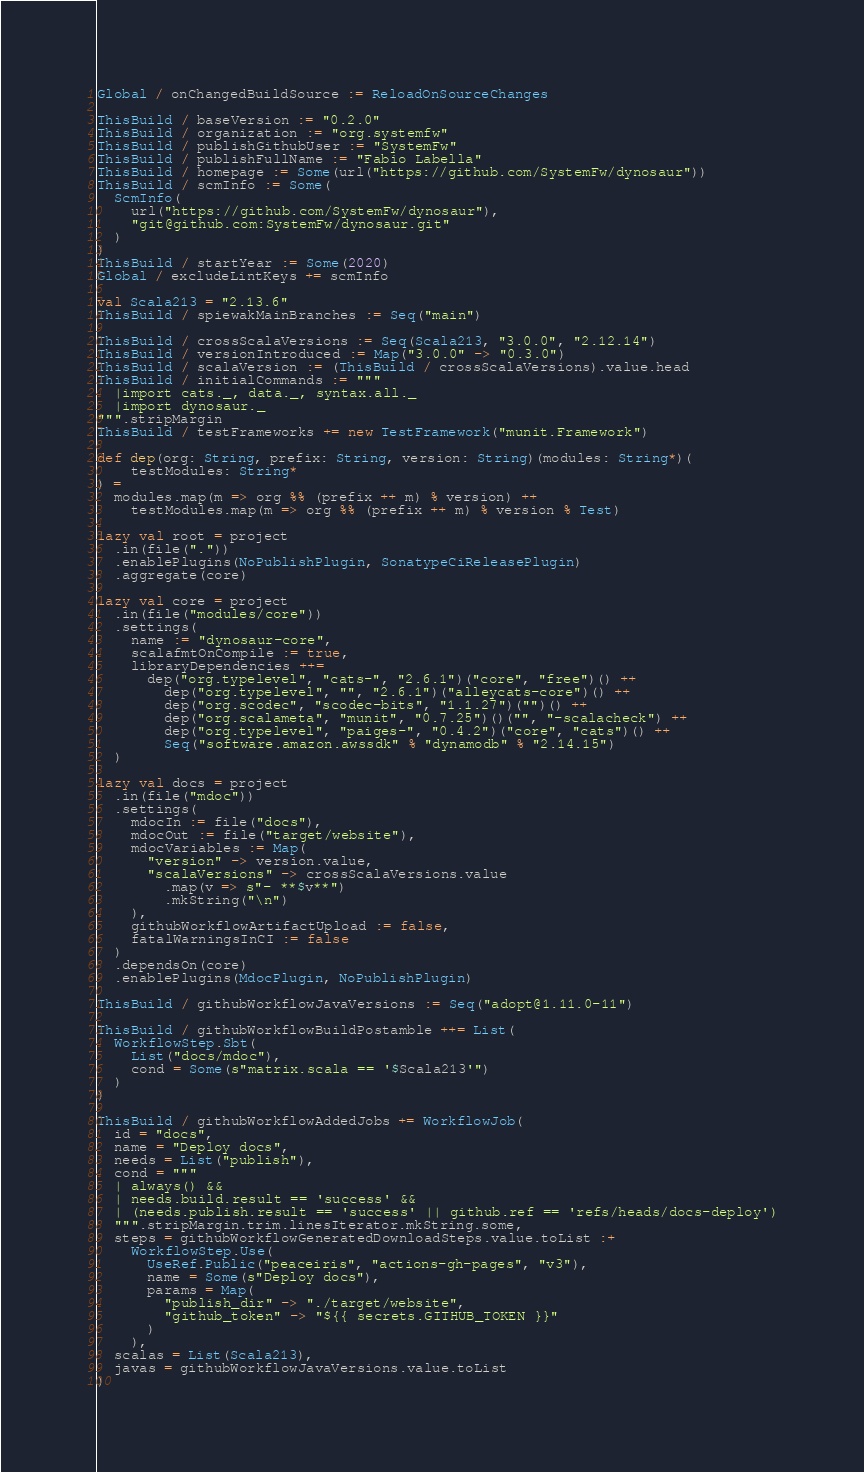<code> <loc_0><loc_0><loc_500><loc_500><_Scala_>Global / onChangedBuildSource := ReloadOnSourceChanges

ThisBuild / baseVersion := "0.2.0"
ThisBuild / organization := "org.systemfw"
ThisBuild / publishGithubUser := "SystemFw"
ThisBuild / publishFullName := "Fabio Labella"
ThisBuild / homepage := Some(url("https://github.com/SystemFw/dynosaur"))
ThisBuild / scmInfo := Some(
  ScmInfo(
    url("https://github.com/SystemFw/dynosaur"),
    "git@github.com:SystemFw/dynosaur.git"
  )
)
ThisBuild / startYear := Some(2020)
Global / excludeLintKeys += scmInfo

val Scala213 = "2.13.6"
ThisBuild / spiewakMainBranches := Seq("main")

ThisBuild / crossScalaVersions := Seq(Scala213, "3.0.0", "2.12.14")
ThisBuild / versionIntroduced := Map("3.0.0" -> "0.3.0")
ThisBuild / scalaVersion := (ThisBuild / crossScalaVersions).value.head
ThisBuild / initialCommands := """
  |import cats._, data._, syntax.all._
  |import dynosaur._
""".stripMargin
ThisBuild / testFrameworks += new TestFramework("munit.Framework")

def dep(org: String, prefix: String, version: String)(modules: String*)(
    testModules: String*
) =
  modules.map(m => org %% (prefix ++ m) % version) ++
    testModules.map(m => org %% (prefix ++ m) % version % Test)

lazy val root = project
  .in(file("."))
  .enablePlugins(NoPublishPlugin, SonatypeCiReleasePlugin)
  .aggregate(core)

lazy val core = project
  .in(file("modules/core"))
  .settings(
    name := "dynosaur-core",
    scalafmtOnCompile := true,
    libraryDependencies ++=
      dep("org.typelevel", "cats-", "2.6.1")("core", "free")() ++
        dep("org.typelevel", "", "2.6.1")("alleycats-core")() ++
        dep("org.scodec", "scodec-bits", "1.1.27")("")() ++
        dep("org.scalameta", "munit", "0.7.25")()("", "-scalacheck") ++
        dep("org.typelevel", "paiges-", "0.4.2")("core", "cats")() ++
        Seq("software.amazon.awssdk" % "dynamodb" % "2.14.15")
  )

lazy val docs = project
  .in(file("mdoc"))
  .settings(
    mdocIn := file("docs"),
    mdocOut := file("target/website"),
    mdocVariables := Map(
      "version" -> version.value,
      "scalaVersions" -> crossScalaVersions.value
        .map(v => s"- **$v**")
        .mkString("\n")
    ),
    githubWorkflowArtifactUpload := false,
    fatalWarningsInCI := false
  )
  .dependsOn(core)
  .enablePlugins(MdocPlugin, NoPublishPlugin)

ThisBuild / githubWorkflowJavaVersions := Seq("adopt@1.11.0-11")

ThisBuild / githubWorkflowBuildPostamble ++= List(
  WorkflowStep.Sbt(
    List("docs/mdoc"),
    cond = Some(s"matrix.scala == '$Scala213'")
  )
)

ThisBuild / githubWorkflowAddedJobs += WorkflowJob(
  id = "docs",
  name = "Deploy docs",
  needs = List("publish"),
  cond = """
  | always() &&
  | needs.build.result == 'success' &&
  | (needs.publish.result == 'success' || github.ref == 'refs/heads/docs-deploy')
  """.stripMargin.trim.linesIterator.mkString.some,
  steps = githubWorkflowGeneratedDownloadSteps.value.toList :+
    WorkflowStep.Use(
      UseRef.Public("peaceiris", "actions-gh-pages", "v3"),
      name = Some(s"Deploy docs"),
      params = Map(
        "publish_dir" -> "./target/website",
        "github_token" -> "${{ secrets.GITHUB_TOKEN }}"
      )
    ),
  scalas = List(Scala213),
  javas = githubWorkflowJavaVersions.value.toList
)
</code> 